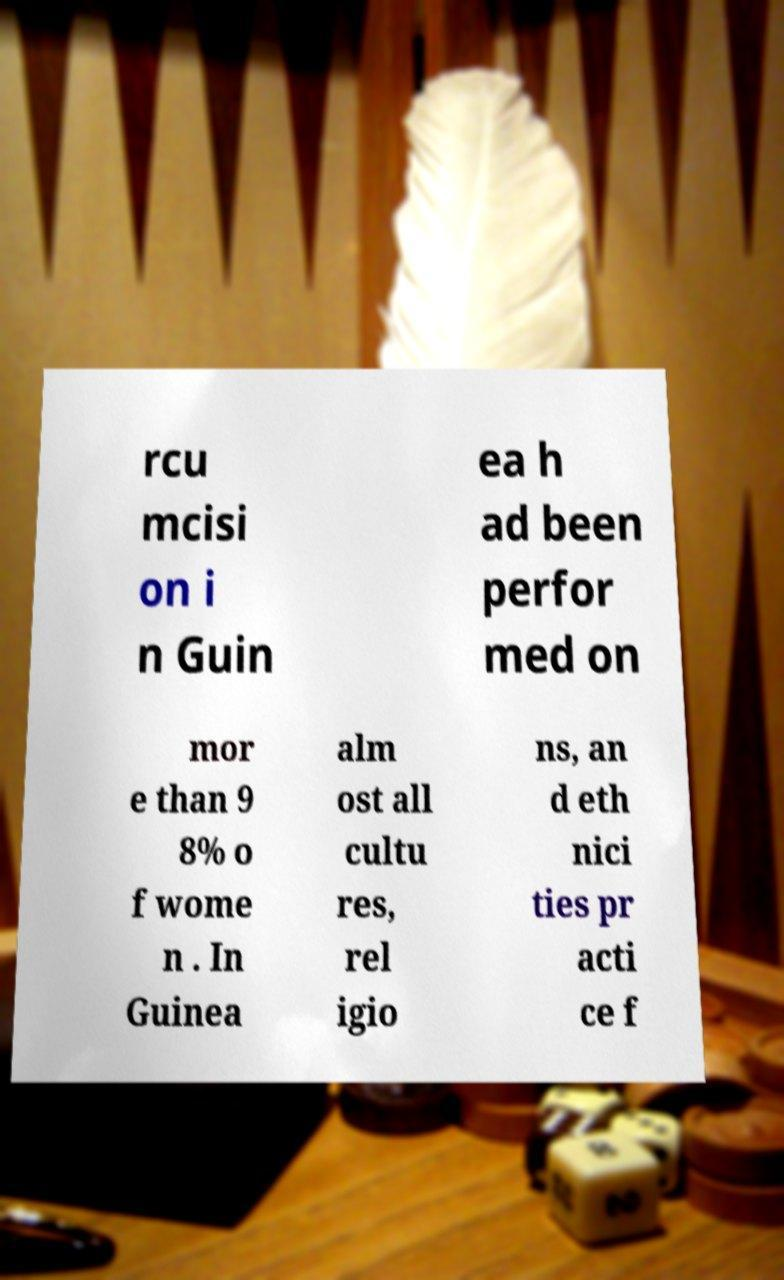There's text embedded in this image that I need extracted. Can you transcribe it verbatim? rcu mcisi on i n Guin ea h ad been perfor med on mor e than 9 8% o f wome n . In Guinea alm ost all cultu res, rel igio ns, an d eth nici ties pr acti ce f 